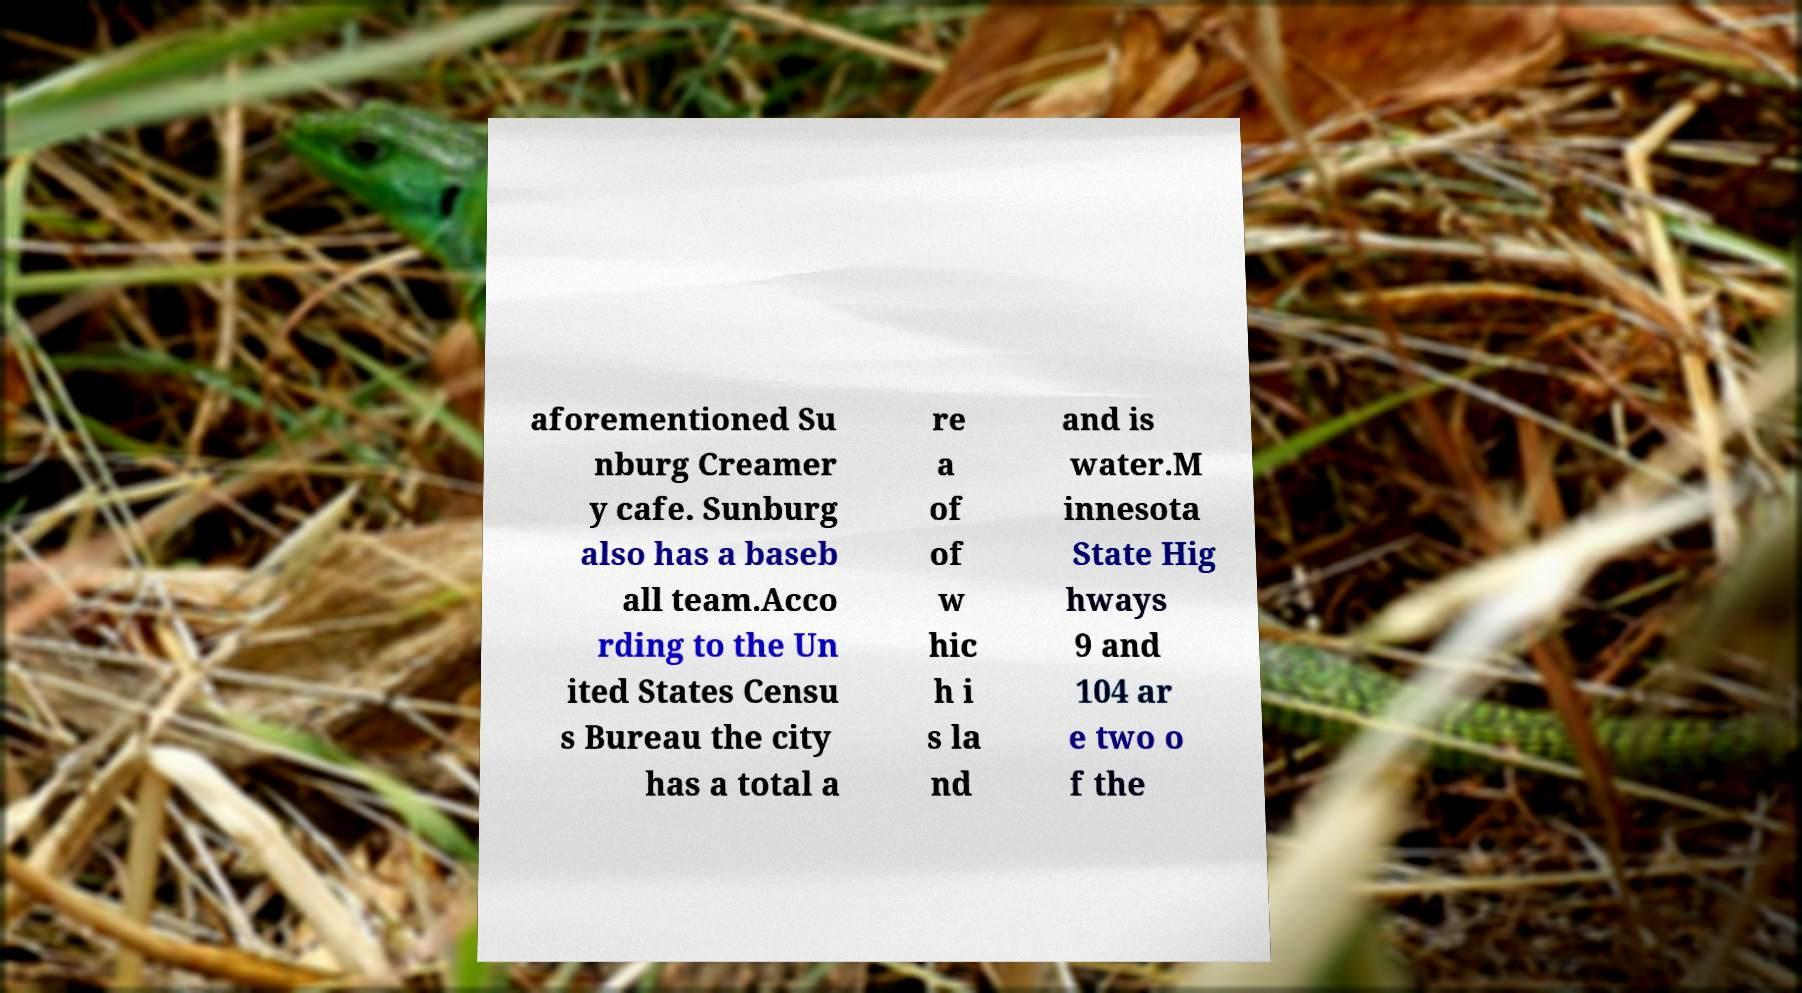For documentation purposes, I need the text within this image transcribed. Could you provide that? aforementioned Su nburg Creamer y cafe. Sunburg also has a baseb all team.Acco rding to the Un ited States Censu s Bureau the city has a total a re a of of w hic h i s la nd and is water.M innesota State Hig hways 9 and 104 ar e two o f the 